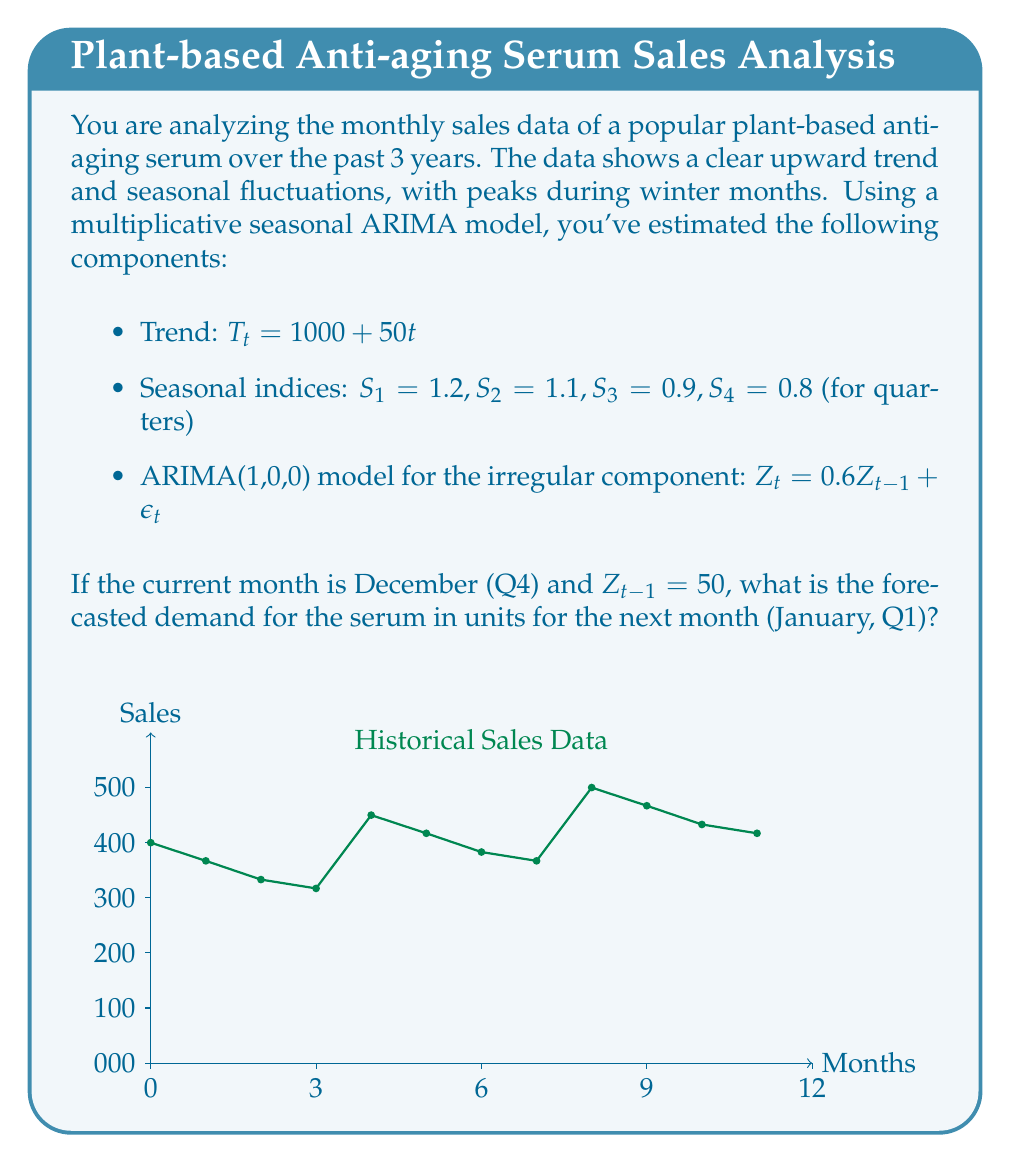Can you solve this math problem? To forecast the demand for the next month, we'll use the multiplicative seasonal ARIMA model:

$Y_t = T_t \times S_t \times Z_t$

Step 1: Calculate the trend component for January (t = 37)
$T_{37} = 1000 + 50(37) = 2850$

Step 2: Identify the seasonal index for January (Q1)
$S_1 = 1.2$

Step 3: Forecast the irregular component
$Z_t = 0.6Z_{t-1} + \epsilon_t$
$Z_{37} = 0.6(50) + 0 = 30$ (assuming $\epsilon_t = 0$ for forecasting)

Step 4: Multiply the components
$Y_{37} = T_{37} \times S_1 \times Z_{37}$
$Y_{37} = 2850 \times 1.2 \times (1 + \frac{30}{100})$
$Y_{37} = 2850 \times 1.2 \times 1.3$
$Y_{37} = 4446$

Therefore, the forecasted demand for January is 4,446 units.
Answer: 4,446 units 